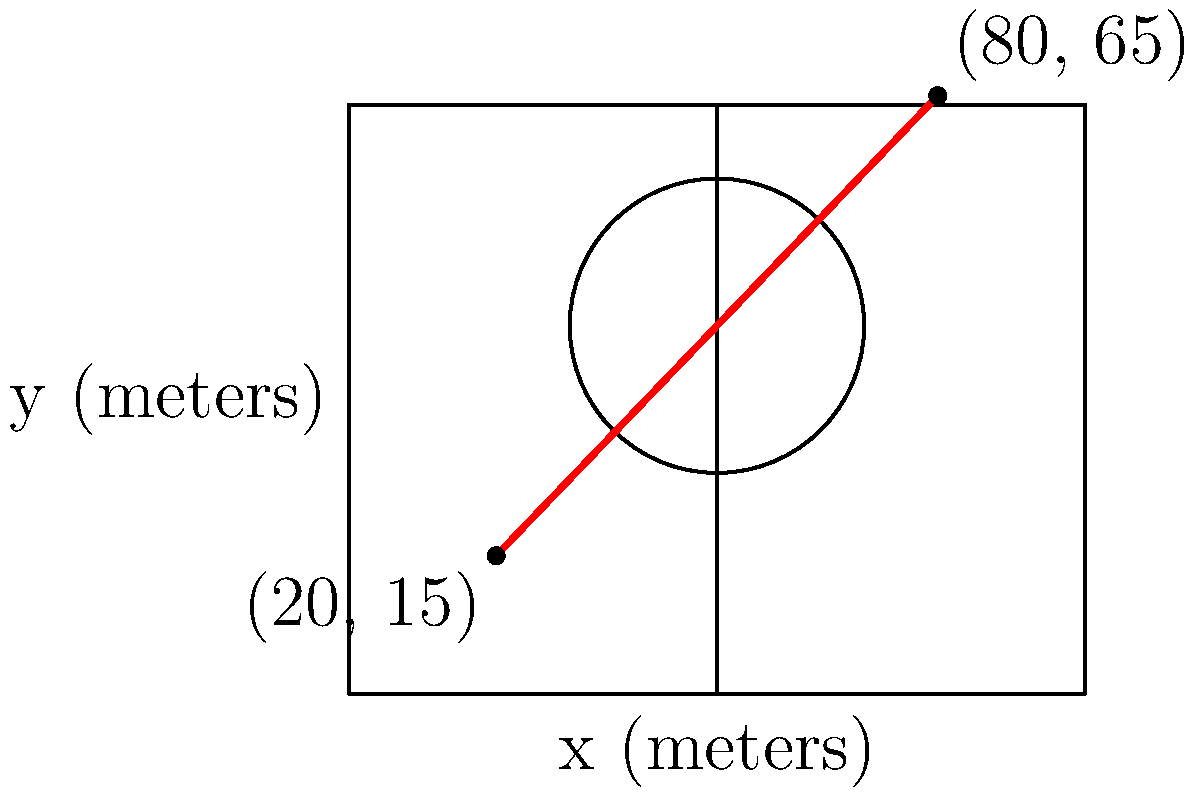In an intense AFLW match, a player makes a critical run from point A (20, 15) to point B (80, 65) on the field, as shown in the diagram. The coordinates represent positions in meters. Calculate the slope of the player's running path, demonstrating her determination to reach the ball. Round your answer to two decimal places. To calculate the slope of the player's running path, we'll use the slope formula:

$$ \text{Slope} = \frac{y_2 - y_1}{x_2 - x_1} $$

Where $(x_1, y_1)$ is the starting point and $(x_2, y_2)$ is the ending point.

Step 1: Identify the coordinates
- Starting point A: $(x_1, y_1) = (20, 15)$
- Ending point B: $(x_2, y_2) = (80, 65)$

Step 2: Apply the slope formula
$$ \text{Slope} = \frac{65 - 15}{80 - 20} = \frac{50}{60} $$

Step 3: Simplify the fraction
$$ \frac{50}{60} = \frac{5}{6} \approx 0.8333... $$

Step 4: Round to two decimal places
$$ 0.83 $$

The positive slope indicates that the player is running upfield, showing her determination to reach a strategic position or the ball.
Answer: 0.83 